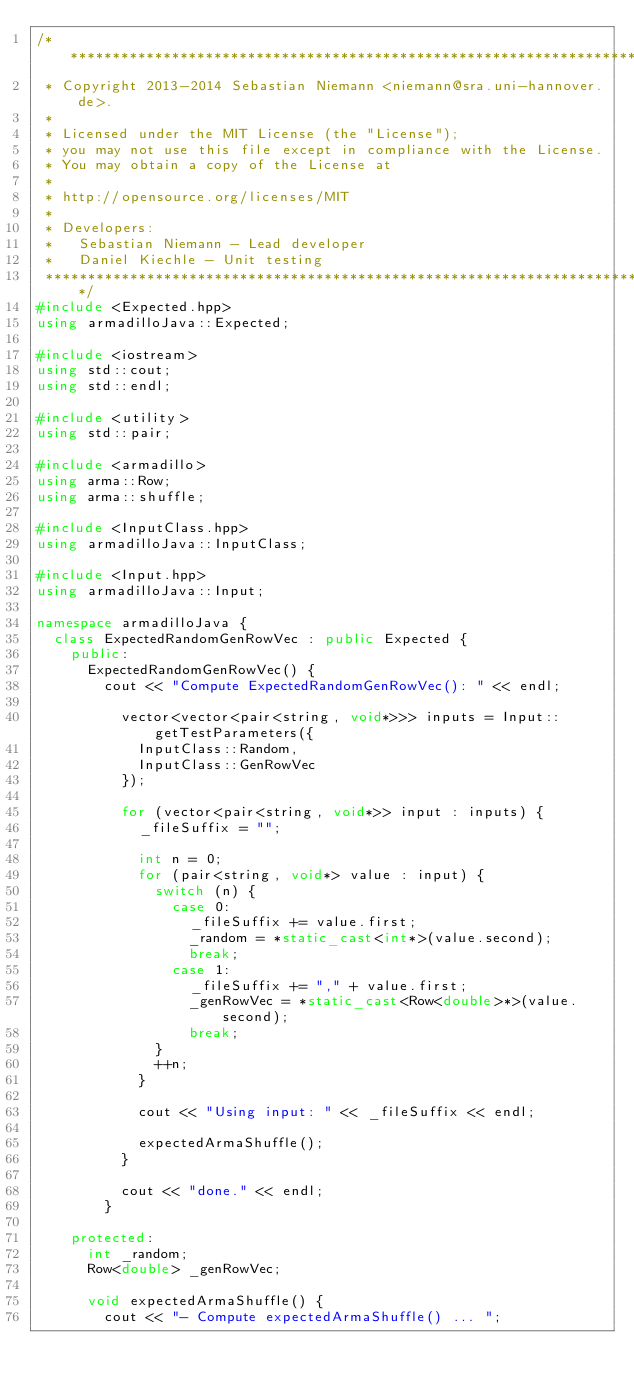Convert code to text. <code><loc_0><loc_0><loc_500><loc_500><_C++_>/*******************************************************************************
 * Copyright 2013-2014 Sebastian Niemann <niemann@sra.uni-hannover.de>.
 * 
 * Licensed under the MIT License (the "License");
 * you may not use this file except in compliance with the License.
 * You may obtain a copy of the License at
 * 
 * http://opensource.org/licenses/MIT
 * 
 * Developers:
 *   Sebastian Niemann - Lead developer
 *   Daniel Kiechle - Unit testing
 ******************************************************************************/
#include <Expected.hpp>
using armadilloJava::Expected;

#include <iostream>
using std::cout;
using std::endl;

#include <utility>
using std::pair;

#include <armadillo>
using arma::Row;
using arma::shuffle;

#include <InputClass.hpp>
using armadilloJava::InputClass;

#include <Input.hpp>
using armadilloJava::Input;

namespace armadilloJava {
  class ExpectedRandomGenRowVec : public Expected {
    public:
      ExpectedRandomGenRowVec() {
        cout << "Compute ExpectedRandomGenRowVec(): " << endl;

          vector<vector<pair<string, void*>>> inputs = Input::getTestParameters({
            InputClass::Random,
            InputClass::GenRowVec
          });

          for (vector<pair<string, void*>> input : inputs) {
            _fileSuffix = "";

            int n = 0;
            for (pair<string, void*> value : input) {
              switch (n) {
                case 0:
                  _fileSuffix += value.first;
                  _random = *static_cast<int*>(value.second);
                  break;
                case 1:
                  _fileSuffix += "," + value.first;
                  _genRowVec = *static_cast<Row<double>*>(value.second);
                  break;
              }
              ++n;
            }

            cout << "Using input: " << _fileSuffix << endl;

            expectedArmaShuffle();
          }

          cout << "done." << endl;
        }

    protected:
      int _random;
      Row<double> _genRowVec;

      void expectedArmaShuffle() {
        cout << "- Compute expectedArmaShuffle() ... ";
</code> 